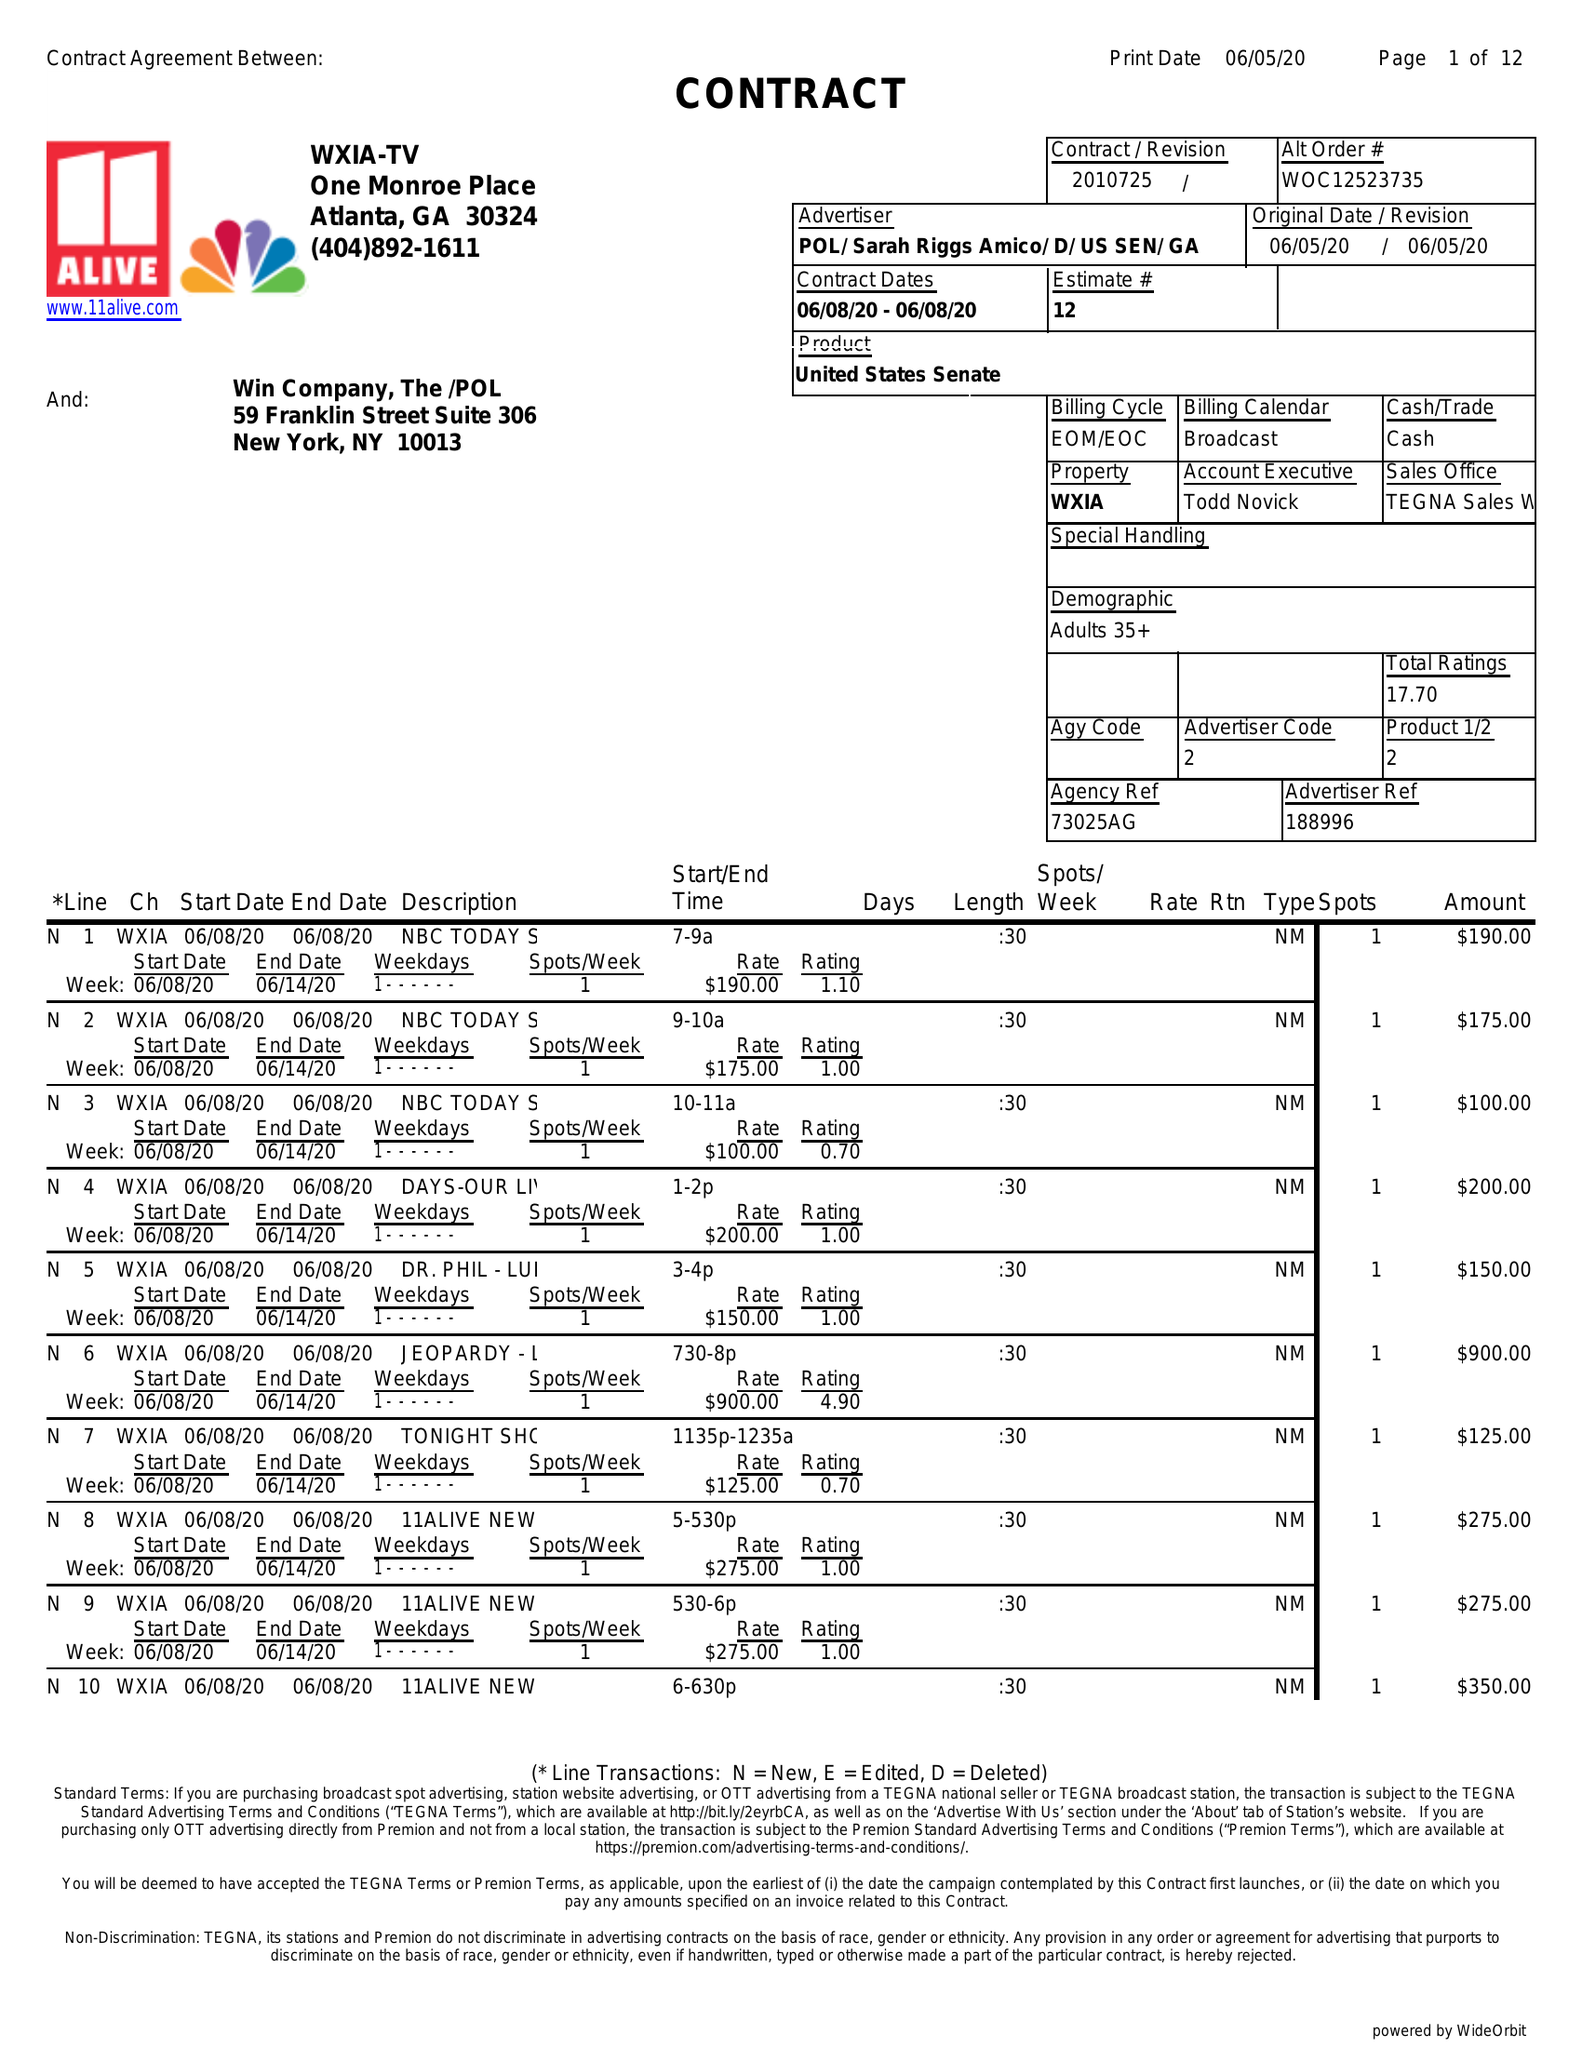What is the value for the flight_to?
Answer the question using a single word or phrase. 06/08/20 